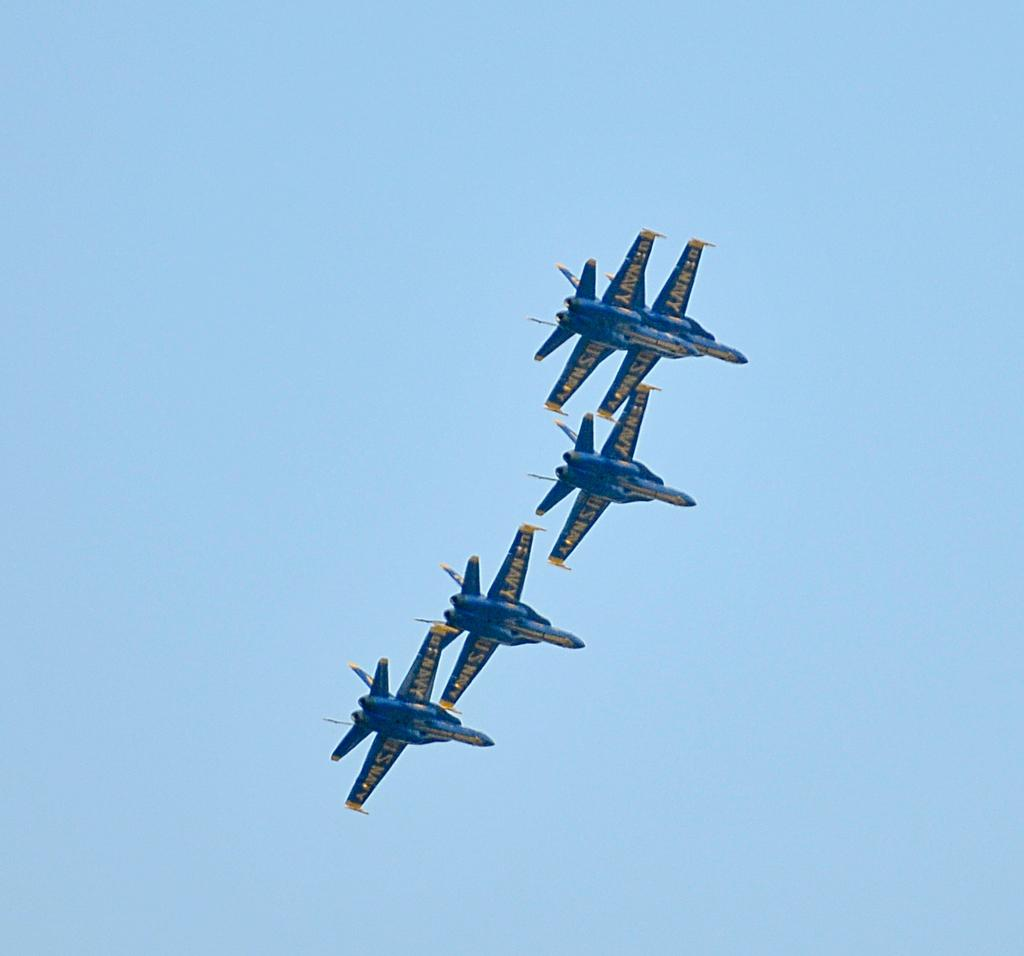What can be seen in the background of the image? There is a sky visible in the image. What is the main subject of the image? Five aircrafts are flying in the image. What color are the aircrafts? The aircrafts are blue in color. What type of wrist jewelry is the queen wearing in the image? There is no queen or wrist jewelry present in the image. 